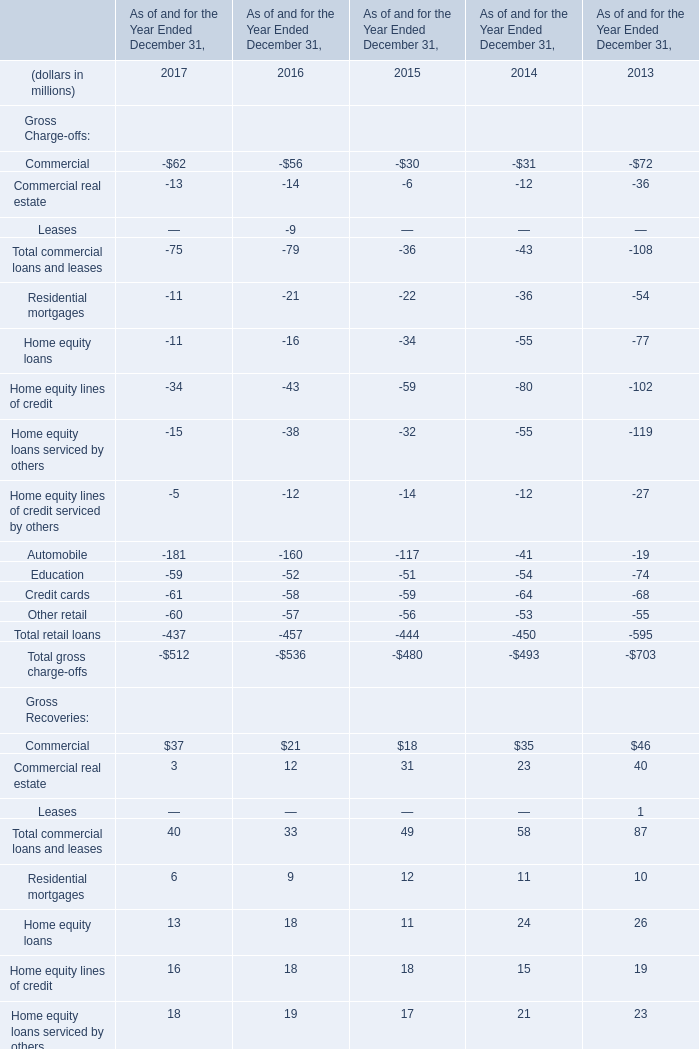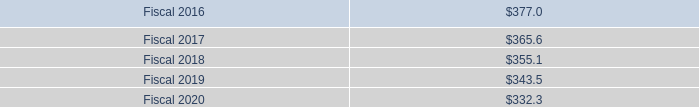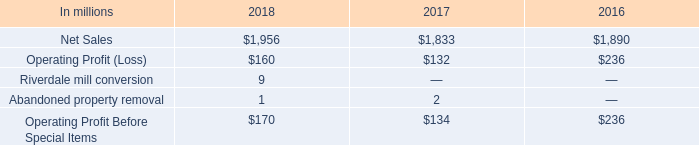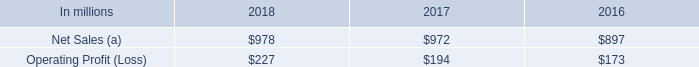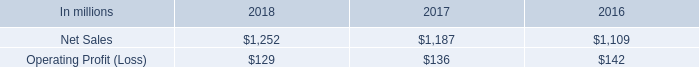How many element exceed the average of and Education Credit cards in 2017? 
Answer: 5. 